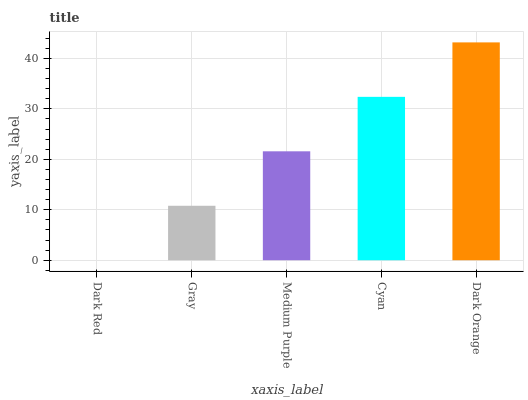Is Dark Red the minimum?
Answer yes or no. Yes. Is Dark Orange the maximum?
Answer yes or no. Yes. Is Gray the minimum?
Answer yes or no. No. Is Gray the maximum?
Answer yes or no. No. Is Gray greater than Dark Red?
Answer yes or no. Yes. Is Dark Red less than Gray?
Answer yes or no. Yes. Is Dark Red greater than Gray?
Answer yes or no. No. Is Gray less than Dark Red?
Answer yes or no. No. Is Medium Purple the high median?
Answer yes or no. Yes. Is Medium Purple the low median?
Answer yes or no. Yes. Is Gray the high median?
Answer yes or no. No. Is Dark Orange the low median?
Answer yes or no. No. 